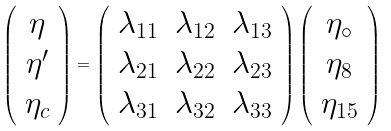Convert formula to latex. <formula><loc_0><loc_0><loc_500><loc_500>\left ( \begin{array} { c } \eta \\ \eta ^ { \prime } \\ \eta _ { c } \end{array} \right ) = \left ( \begin{array} { c c c } \lambda _ { 1 1 } & \lambda _ { 1 2 } & \lambda _ { 1 3 } \\ \lambda _ { 2 1 } & \lambda _ { 2 2 } & \lambda _ { 2 3 } \\ \lambda _ { 3 1 } & \lambda _ { 3 2 } & \lambda _ { 3 3 } \end{array} \right ) \left ( \begin{array} { c } \eta _ { \circ } \\ \eta _ { 8 } \\ \eta _ { 1 5 } \end{array} \right )</formula> 